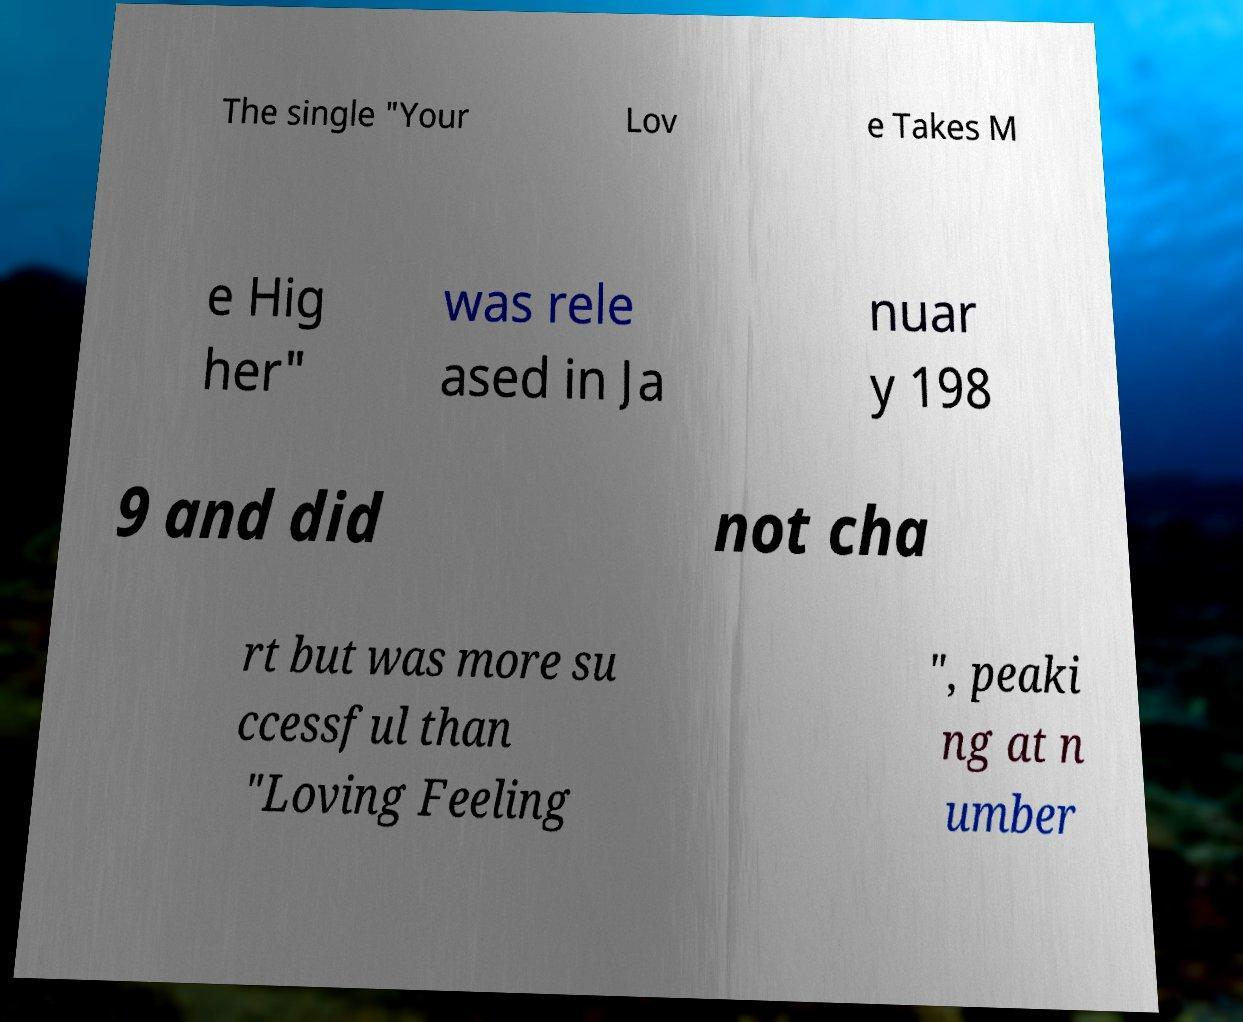Could you extract and type out the text from this image? The single "Your Lov e Takes M e Hig her" was rele ased in Ja nuar y 198 9 and did not cha rt but was more su ccessful than "Loving Feeling ", peaki ng at n umber 